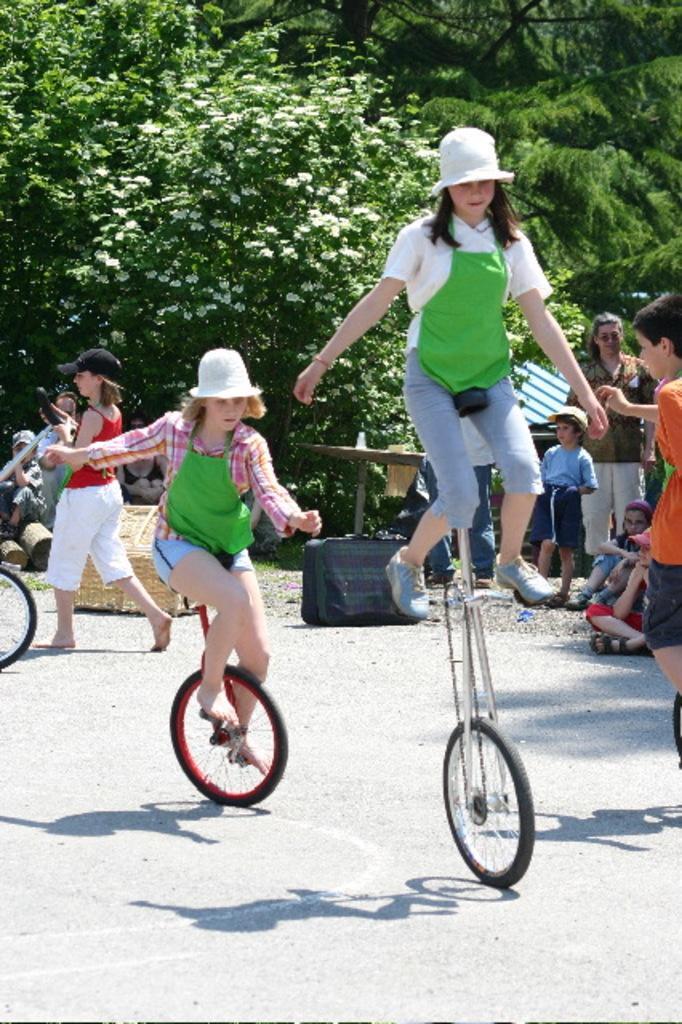How would you summarize this image in a sentence or two? There are two women riding a unicycle as we can see in the middle of this image. There is one girl holding a unicycle on the left side of this image and there is a group of persons on the right side of this image. We can see some trees in the background. 